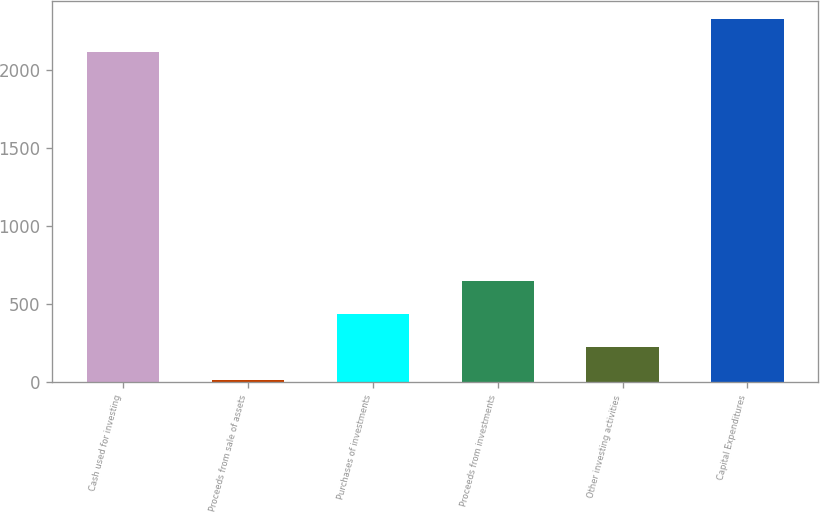Convert chart. <chart><loc_0><loc_0><loc_500><loc_500><bar_chart><fcel>Cash used for investing<fcel>Proceeds from sale of assets<fcel>Purchases of investments<fcel>Proceeds from investments<fcel>Other investing activities<fcel>Capital Expenditures<nl><fcel>2113.4<fcel>11.1<fcel>434.6<fcel>646.35<fcel>222.85<fcel>2325.15<nl></chart> 